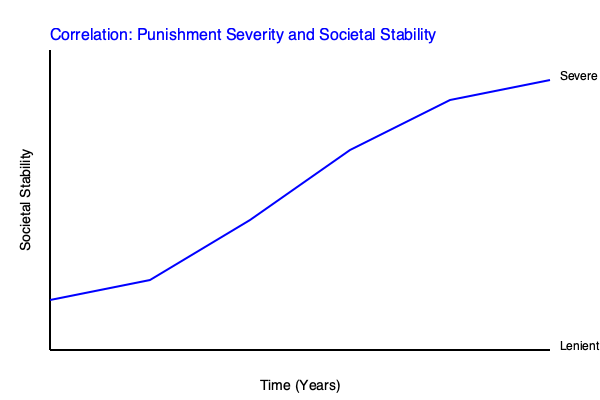Based on the line graph, what is the relationship between the severity of punishment and societal stability over time? How might this data support or challenge the effectiveness of a punitive approach to post-conflict justice? To analyze the graph and answer the question, let's follow these steps:

1. Interpret the axes:
   - X-axis represents time (years)
   - Y-axis represents societal stability
   - The blue line indicates the correlation between punishment severity and societal stability

2. Observe the trend:
   - The line starts high on the y-axis and moves downward as it progresses along the x-axis
   - This indicates that as time passes, societal stability increases

3. Understand the implications:
   - The graph suggests that as punishment becomes more severe (moving from bottom to top on the y-axis), societal stability decreases
   - Conversely, as punishment becomes more lenient (moving from top to bottom on the y-axis), societal stability increases

4. Analyze the relationship:
   - There appears to be an inverse relationship between punishment severity and societal stability
   - As punishment severity decreases, societal stability increases

5. Consider the implications for post-conflict justice:
   - The data challenges the effectiveness of a highly punitive approach
   - It suggests that more lenient approaches to post-conflict justice may lead to greater societal stability over time

6. Reflect on potential explanations:
   - Lenient approaches might promote reconciliation and healing
   - Severe punishments could perpetuate cycles of violence or resentment
   - Other factors not shown in the graph (e.g., economic development, institutional reforms) may also influence stability

7. Acknowledge limitations:
   - Correlation does not imply causation
   - The graph doesn't account for other variables that might affect societal stability
   - Context-specific factors in different post-conflict scenarios are not represented

In conclusion, while the graph challenges the effectiveness of a punitive approach to post-conflict justice, it's important to consider the complexities of real-world scenarios and the potential influence of other factors not represented in this simplified model.
Answer: Inverse relationship: as punishment severity decreases, societal stability increases over time, challenging the effectiveness of highly punitive post-conflict justice approaches. 